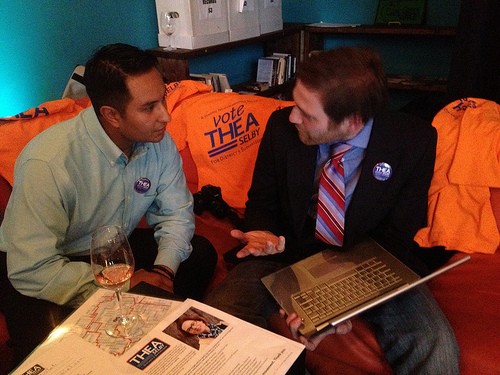<image>
Can you confirm if the button is on the shirt? Yes. Looking at the image, I can see the button is positioned on top of the shirt, with the shirt providing support. 